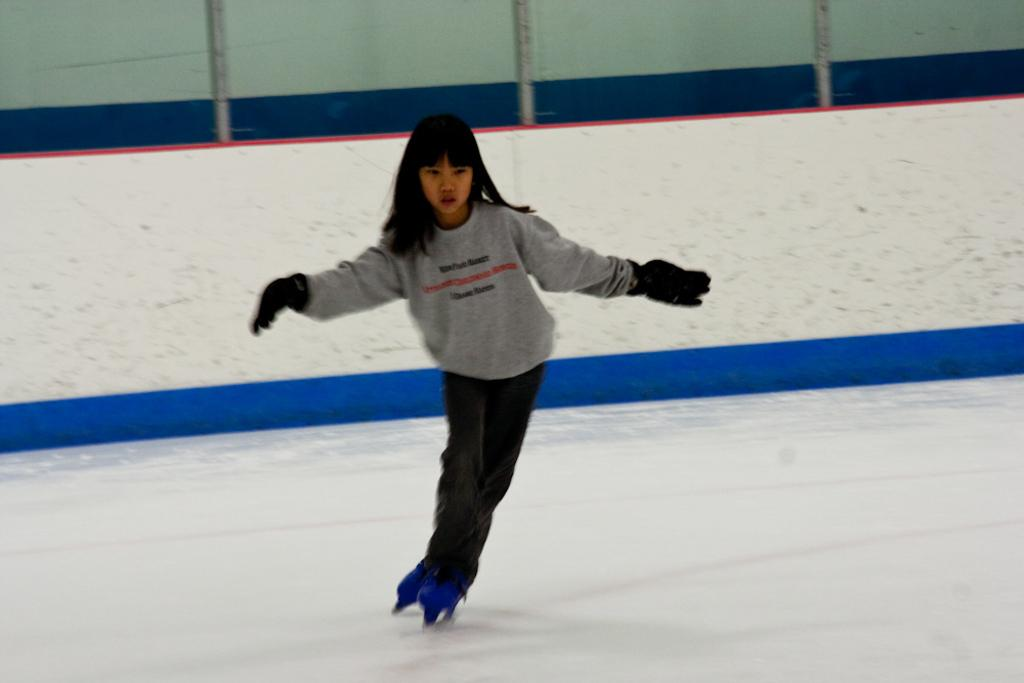Who or what is present in the image? There is a person in the image. What is the person wearing? The person is wearing clothes. What activity is the person engaged in? The person is skating on ice. What can be seen at the top of the image? There are poles at the top of the image. What type of yoke is being used by the giants in the image? There are no giants or yokes present in the image; it features a person skating on ice. 